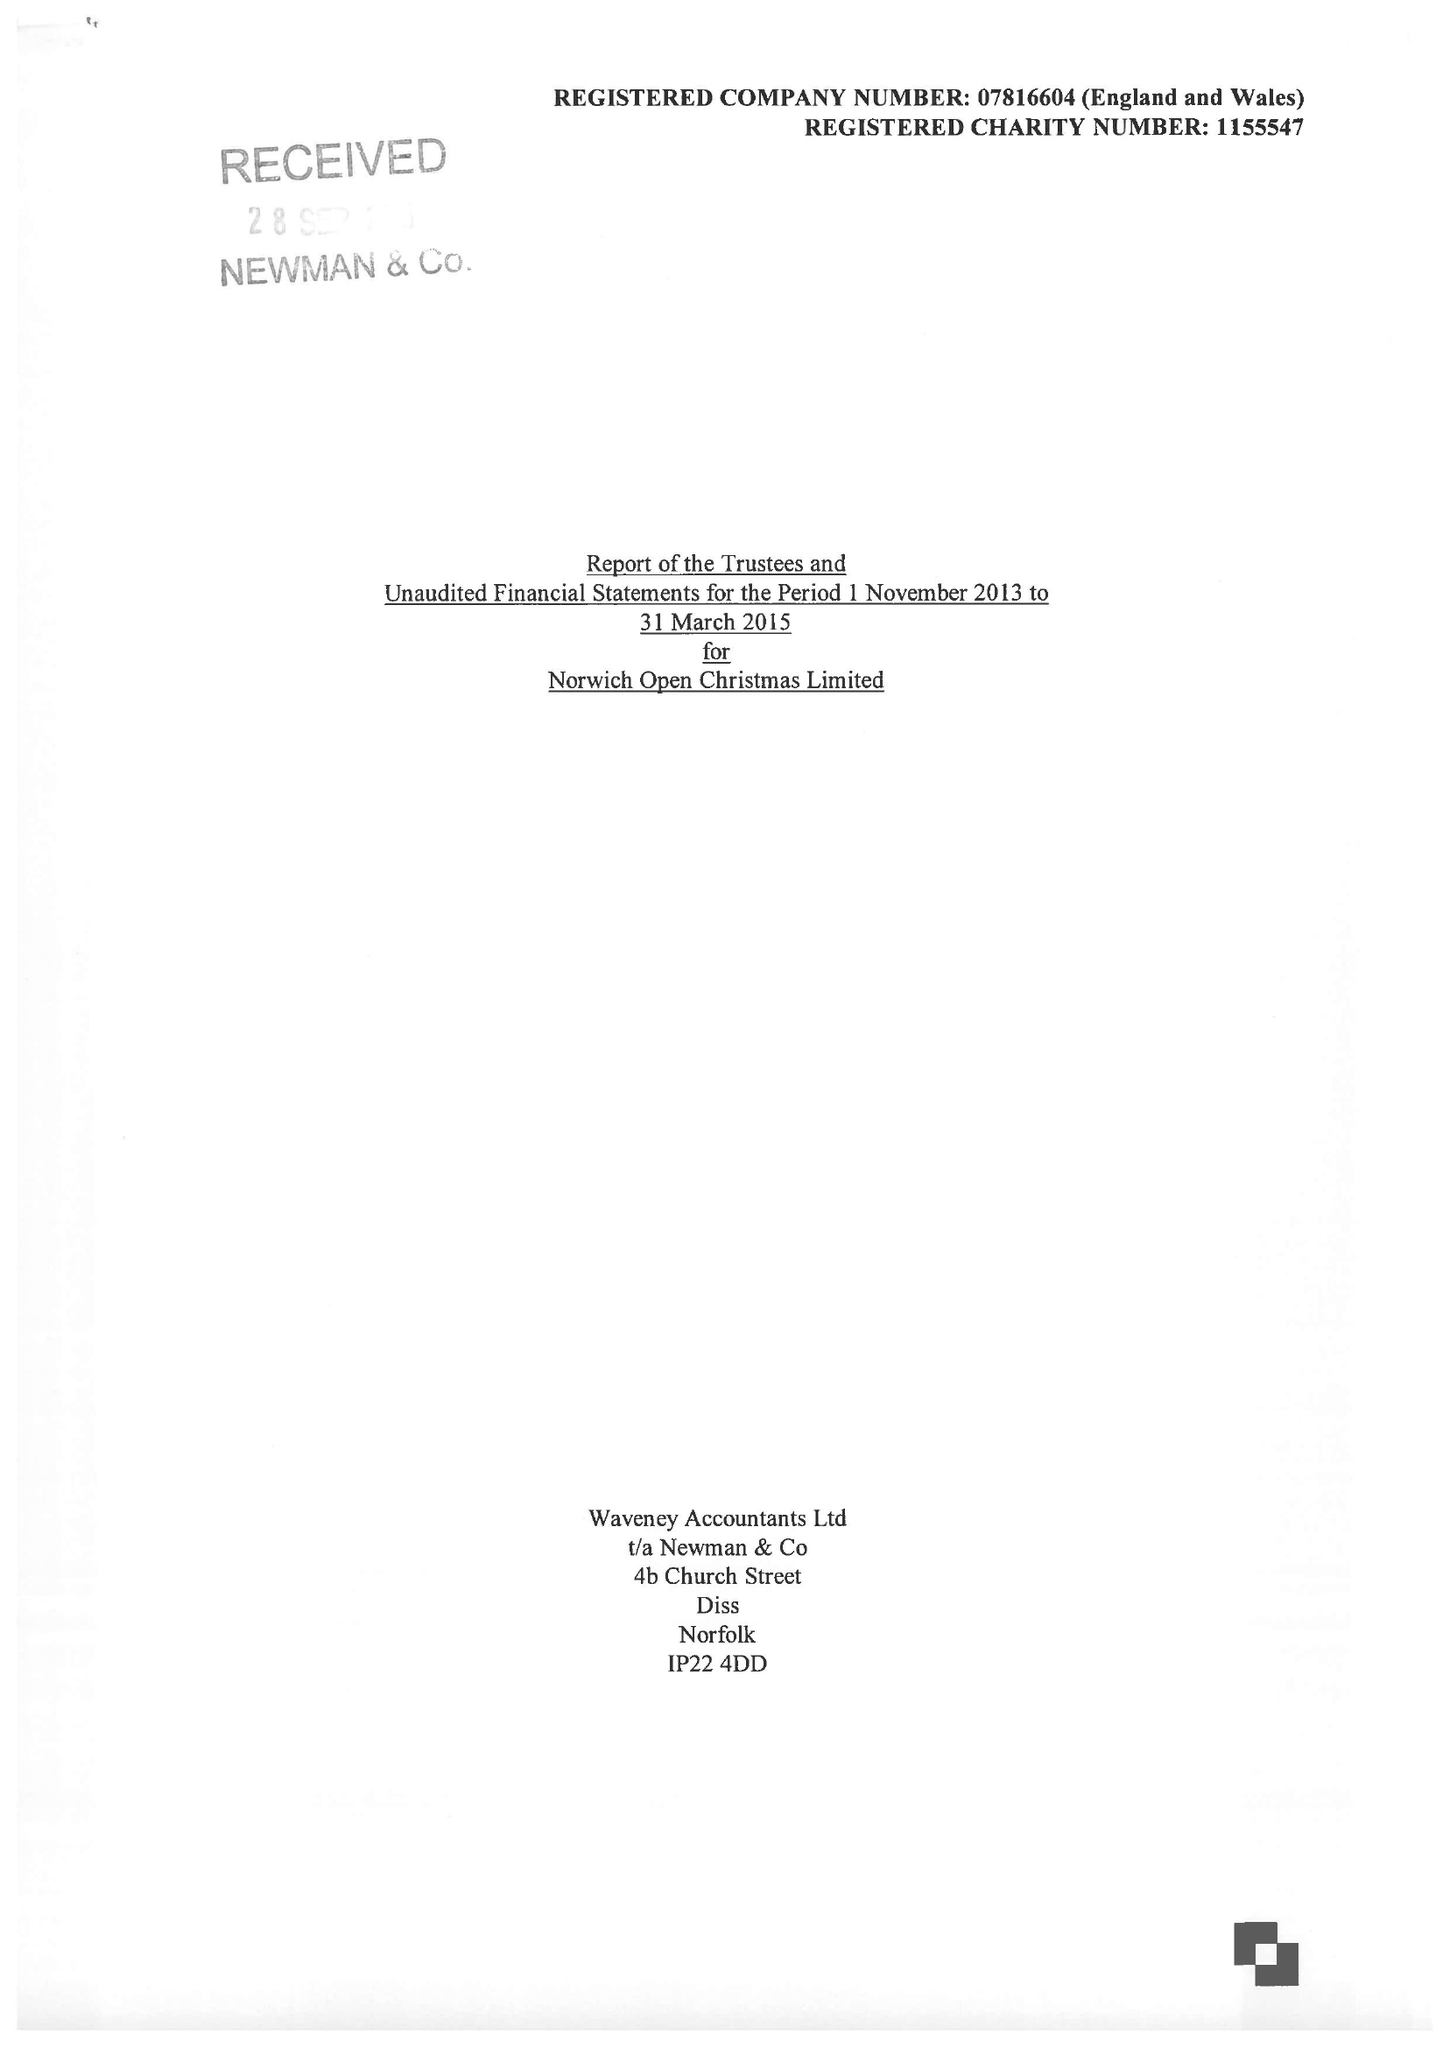What is the value for the address__postcode?
Answer the question using a single word or phrase. NR13 5AA 